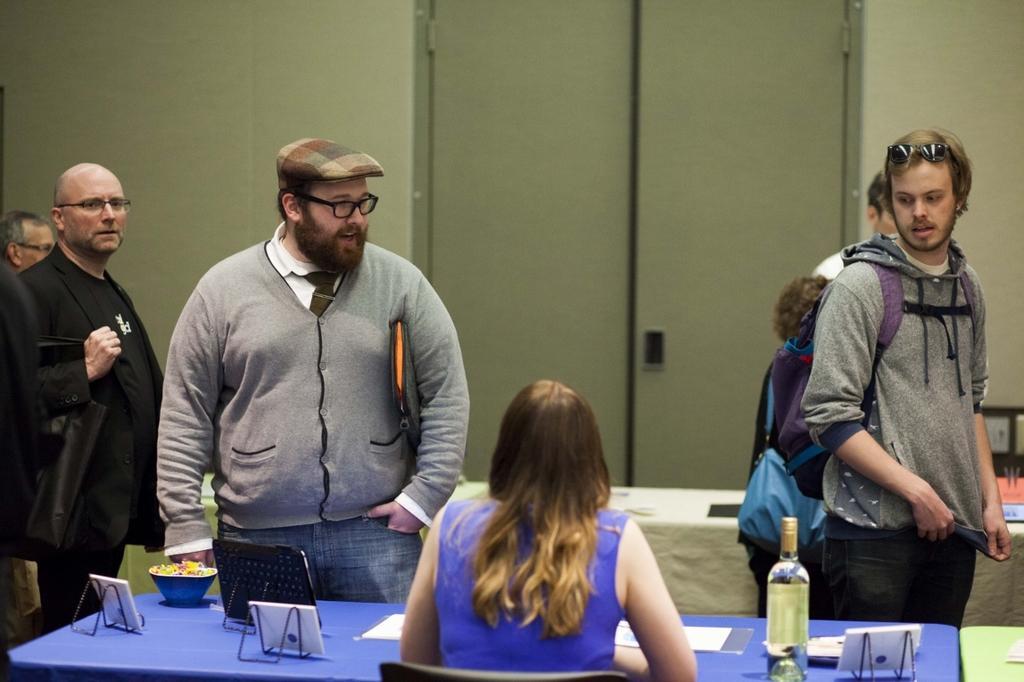Can you describe this image briefly? In this picture we can see a group of people standing and a woman is sitting on a chair. In front of the woman there is a table and on the table there is a bottle, bowl, papers and some objects. Behind the people, it looks like another table which is covered by a cloth. Behind the table there is a door and walls. 